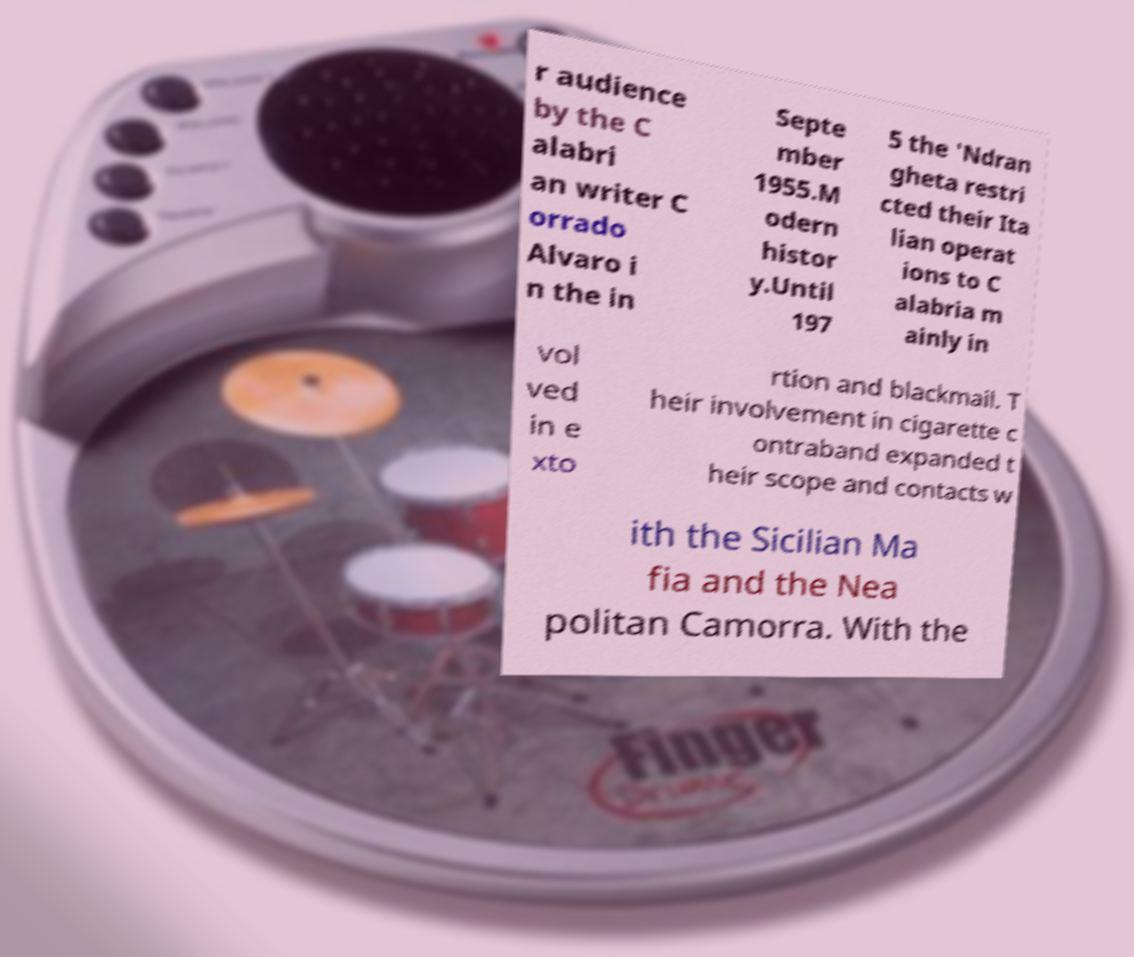I need the written content from this picture converted into text. Can you do that? r audience by the C alabri an writer C orrado Alvaro i n the in Septe mber 1955.M odern histor y.Until 197 5 the 'Ndran gheta restri cted their Ita lian operat ions to C alabria m ainly in vol ved in e xto rtion and blackmail. T heir involvement in cigarette c ontraband expanded t heir scope and contacts w ith the Sicilian Ma fia and the Nea politan Camorra. With the 